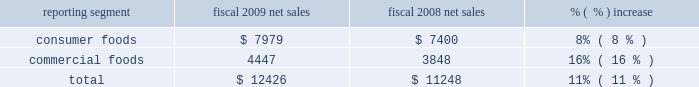Credits and deductions identified in fiscal 2010 that related to prior periods .
These benefits were offset , in part , by unfavorable tax consequences of the patient protection and affordable care act and the health care and education reconciliation act of 2010 .
The company expects its effective tax rate in fiscal 2011 , exclusive of any unusual transactions or tax events , to be approximately 34% ( 34 % ) .
Equity method investment earnings we include our share of the earnings of certain affiliates based on our economic ownership interest in the affiliates .
Significant affiliates produce and market potato products for retail and foodservice customers .
Our share of earnings from our equity method investments was $ 22 million ( $ 2 million in the consumer foods segment and $ 20 million in the commercial foods segment ) and $ 24 million ( $ 3 million in the consumer foods segment and $ 21 million in the commercial foods segment ) in fiscal 2010 and 2009 , respectively .
Equity method investment earnings in the commercial foods segment reflects continued difficult market conditions for our foreign and domestic potato ventures .
Results of discontinued operations our discontinued operations generated an after-tax loss of $ 22 million in fiscal 2010 and earnings of $ 361 million in fiscal 2009 .
In fiscal 2010 , we decided to divest our dehydrated vegetable operations .
As a result of this decision , we recognized an after-tax impairment charge of $ 40 million in fiscal 2010 , representing a write- down of the carrying value of the related long-lived assets to fair value , based on the anticipated sales proceeds .
In fiscal 2009 , we completed the sale of the trading and merchandising operations and recognized an after-tax gain on the disposition of approximately $ 301 million .
In the fourth quarter of fiscal 2009 , we decided to sell certain small foodservice brands .
The sale of these brands was completed in june 2009 .
We recognized after-tax impairment charges of $ 6 million in fiscal 2009 , in anticipation of this divestiture .
Earnings per share our diluted earnings per share in fiscal 2010 were $ 1.62 ( including earnings of $ 1.67 per diluted share from continuing operations and a loss of $ 0.05 per diluted share from discontinued operations ) .
Our diluted earnings per share in fiscal 2009 were $ 2.15 ( including earnings of $ 1.36 per diluted share from continuing operations and $ 0.79 per diluted share from discontinued operations ) see 201citems impacting comparability 201d above as several other significant items affected the comparability of year-over-year results of operations .
2009 vs .
2008 net sales ( $ in millions ) reporting segment fiscal 2009 net sales fiscal 2008 net sales % (  % ) increase .
Overall , our net sales increased $ 1.18 billion to $ 12.43 billion in fiscal 2009 , reflecting improved pricing and mix in the consumer foods segment and increased pricing in the milling and specialty potato operations of the commercial foods segment , as well as an additional week in fiscal 2009 .
Consumer foods net sales for fiscal 2009 were $ 7.98 billion , an increase of 8% ( 8 % ) compared to fiscal 2008 .
Results reflected an increase of 7% ( 7 % ) from improved net pricing and product mix and flat volume .
Volume reflected a benefit of approximately 2% ( 2 % ) in fiscal 2009 due to the inclusion of an additional week of results .
The strengthening of the u.s .
Dollar relative to foreign currencies resulted in a reduction of net sales of approximately 1% ( 1 % ) as compared to fiscal 2008. .
What percentage of fiscal 2008 total net sales was due to commercial foods? 
Computations: (3848 / 11248)
Answer: 0.34211. 